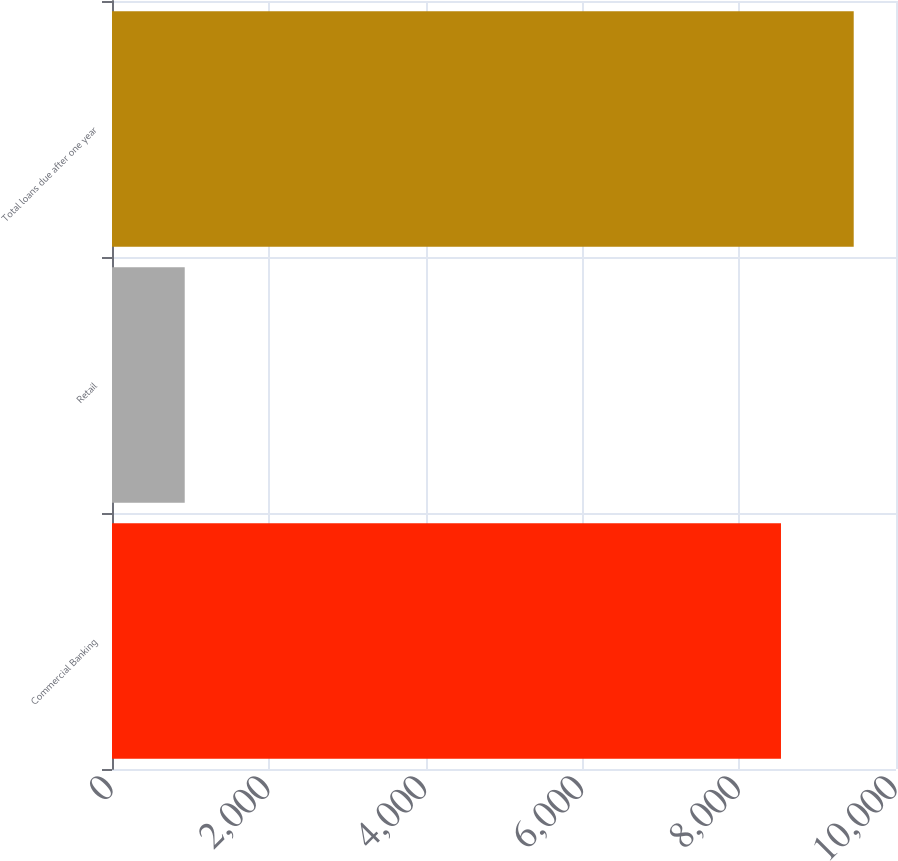Convert chart to OTSL. <chart><loc_0><loc_0><loc_500><loc_500><bar_chart><fcel>Commercial Banking<fcel>Retail<fcel>Total loans due after one year<nl><fcel>8532.9<fcel>927.7<fcel>9460.6<nl></chart> 